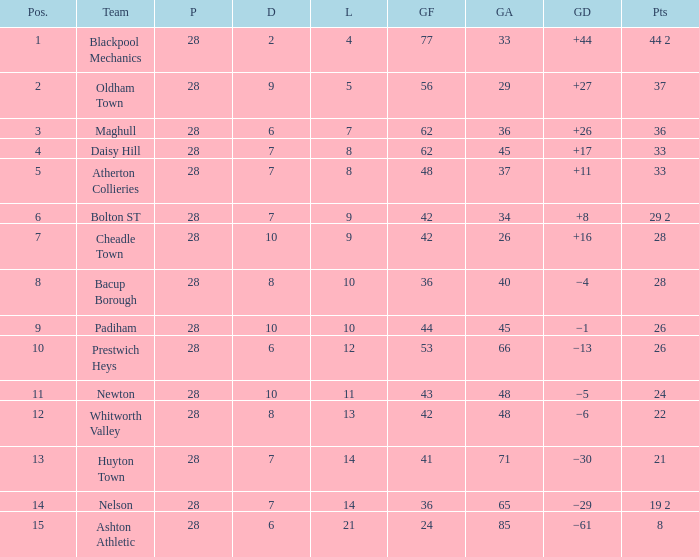What is the lowest drawn for entries with a lost of 13? 8.0. 